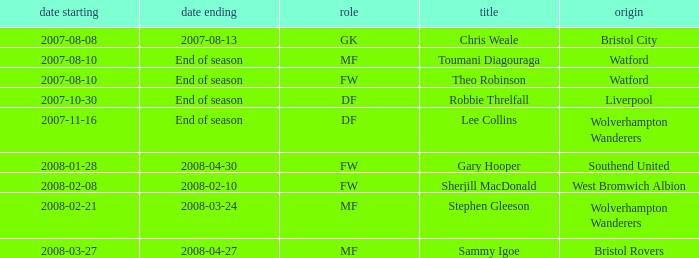What was the name for the row with Date From of 2008-02-21? Stephen Gleeson. 